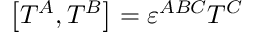Convert formula to latex. <formula><loc_0><loc_0><loc_500><loc_500>\left [ T ^ { A } , T ^ { B } \right ] = \varepsilon ^ { A B C } T ^ { C } \,</formula> 